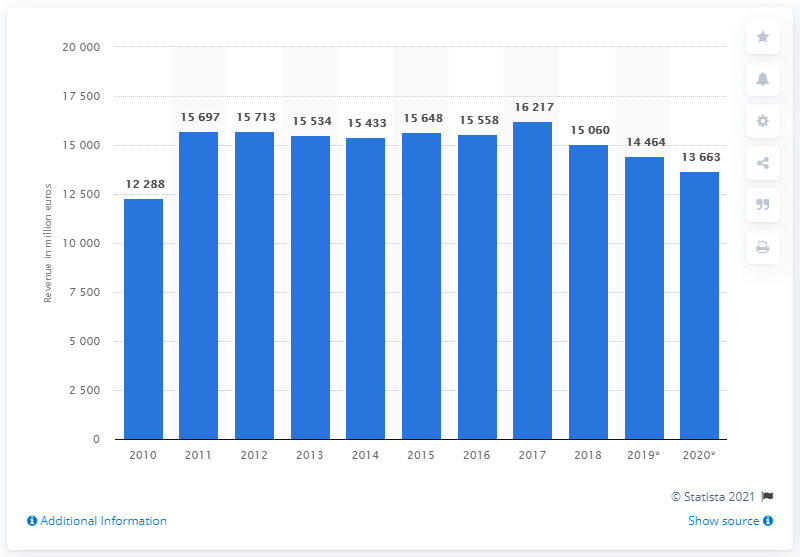Specify some key components in this picture. BASF reported a revenue of approximately 136,630 in the Performance Products segment in 2019. 